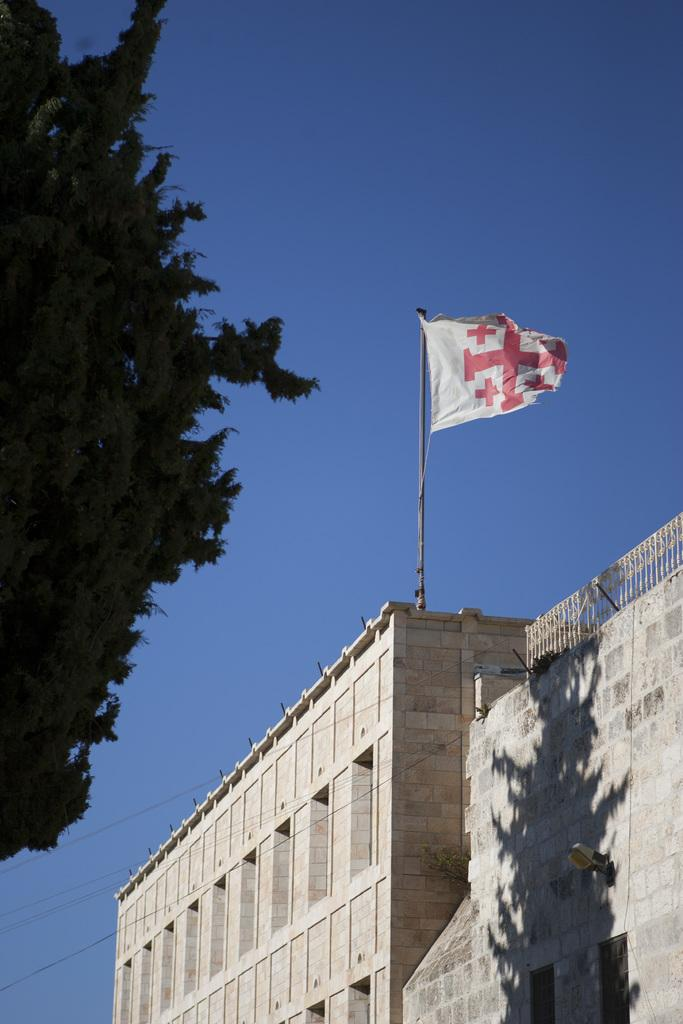What structure is the main subject of the image? There is a building in the image. What is attached to the building? There is a flag on the building. What type of vegetation is located to the left of the building? There is a tree to the left of the building. What can be seen in the background of the image? The sky is visible in the background of the image. What type of tank is visible in the image? There is no tank present in the image; it features a building with a flag and a tree. Can you tell me how many people are asking for help in the image? There is no indication of people asking for help in the image. 